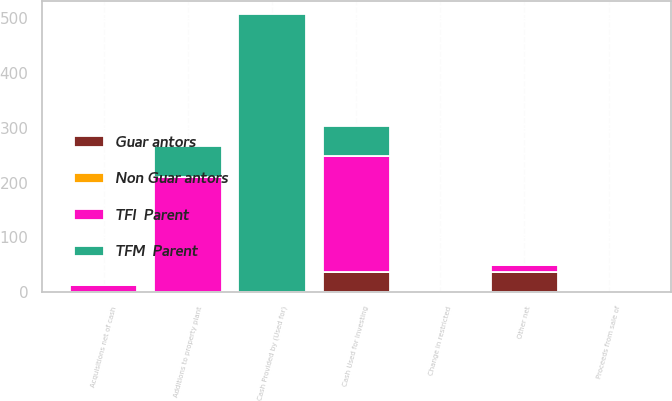<chart> <loc_0><loc_0><loc_500><loc_500><stacked_bar_chart><ecel><fcel>Cash Provided by (Used for)<fcel>Additions to property plant<fcel>Change in restricted<fcel>Proceeds from sale of<fcel>Acquisitions net of cash<fcel>Other net<fcel>Cash Used for Investing<nl><fcel>Guar antors<fcel>0<fcel>0<fcel>0<fcel>0<fcel>0<fcel>37<fcel>37<nl><fcel>TFM  Parent<fcel>507<fcel>56<fcel>0<fcel>0<fcel>0<fcel>1<fcel>55<nl><fcel>TFI  Parent<fcel>0<fcel>211<fcel>0<fcel>0<fcel>13<fcel>12<fcel>212<nl><fcel>Non Guar antors<fcel>0<fcel>0<fcel>0<fcel>0<fcel>0<fcel>0<fcel>0<nl></chart> 